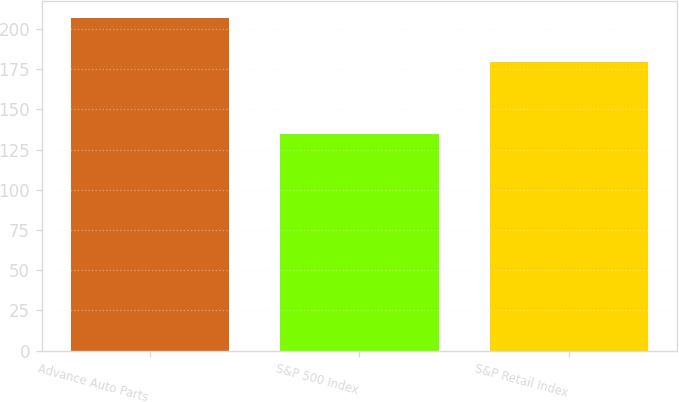Convert chart. <chart><loc_0><loc_0><loc_500><loc_500><bar_chart><fcel>Advance Auto Parts<fcel>S&P 500 Index<fcel>S&P Retail Index<nl><fcel>206.86<fcel>134.96<fcel>179.79<nl></chart> 